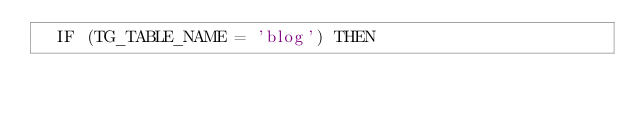Convert code to text. <code><loc_0><loc_0><loc_500><loc_500><_SQL_>  IF (TG_TABLE_NAME = 'blog') THEN</code> 